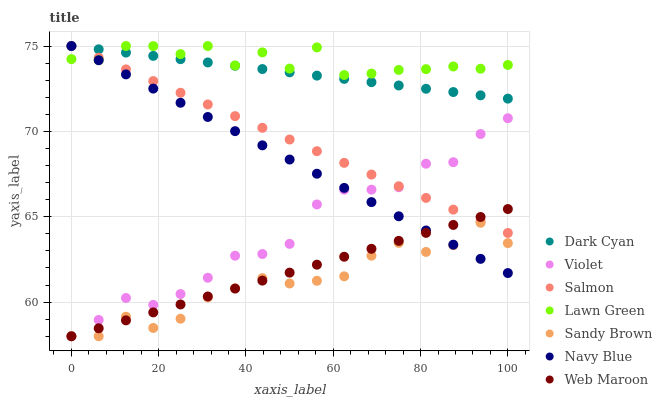Does Sandy Brown have the minimum area under the curve?
Answer yes or no. Yes. Does Lawn Green have the maximum area under the curve?
Answer yes or no. Yes. Does Navy Blue have the minimum area under the curve?
Answer yes or no. No. Does Navy Blue have the maximum area under the curve?
Answer yes or no. No. Is Salmon the smoothest?
Answer yes or no. Yes. Is Lawn Green the roughest?
Answer yes or no. Yes. Is Navy Blue the smoothest?
Answer yes or no. No. Is Navy Blue the roughest?
Answer yes or no. No. Does Web Maroon have the lowest value?
Answer yes or no. Yes. Does Navy Blue have the lowest value?
Answer yes or no. No. Does Dark Cyan have the highest value?
Answer yes or no. Yes. Does Web Maroon have the highest value?
Answer yes or no. No. Is Violet less than Dark Cyan?
Answer yes or no. Yes. Is Dark Cyan greater than Web Maroon?
Answer yes or no. Yes. Does Sandy Brown intersect Navy Blue?
Answer yes or no. Yes. Is Sandy Brown less than Navy Blue?
Answer yes or no. No. Is Sandy Brown greater than Navy Blue?
Answer yes or no. No. Does Violet intersect Dark Cyan?
Answer yes or no. No. 